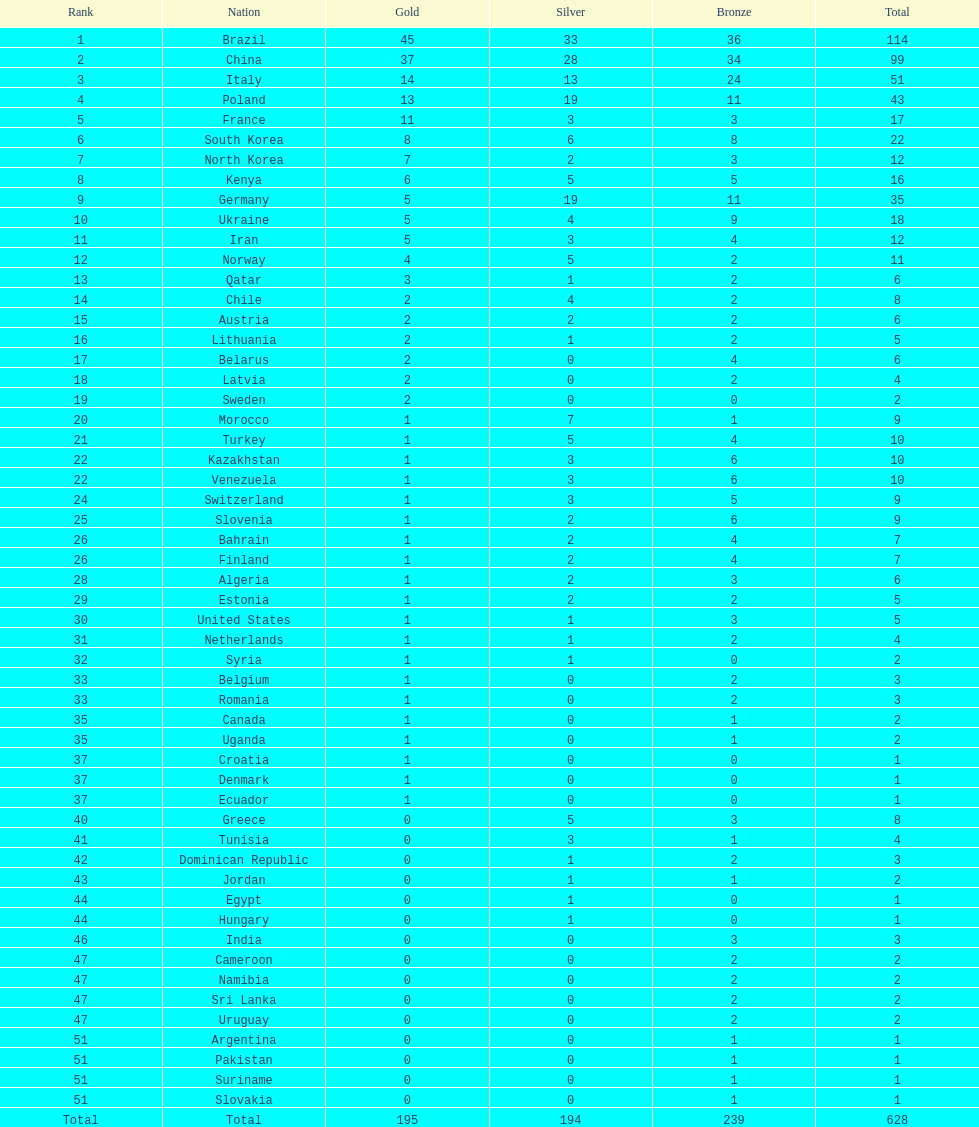Which type of medal does belarus not have? Silver. 